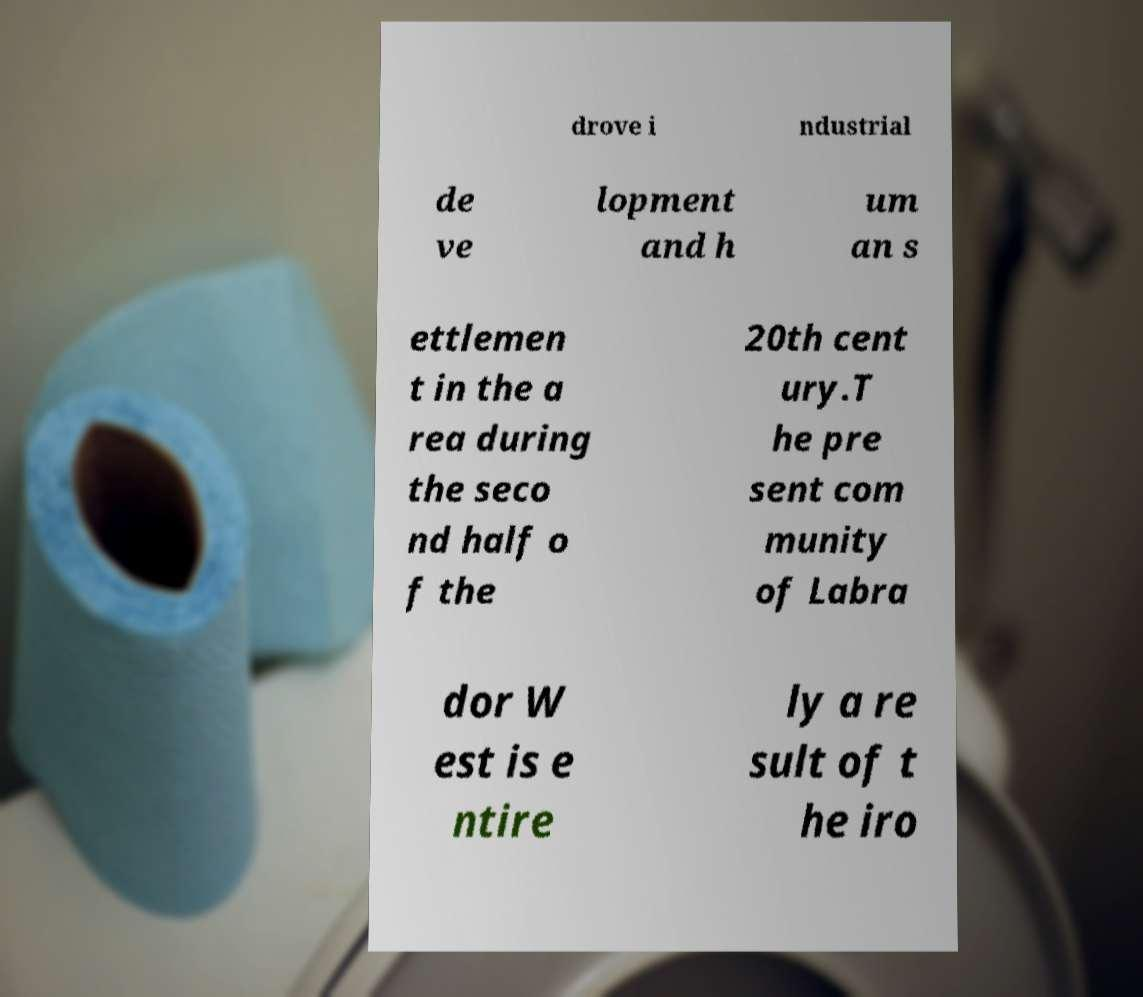Please read and relay the text visible in this image. What does it say? drove i ndustrial de ve lopment and h um an s ettlemen t in the a rea during the seco nd half o f the 20th cent ury.T he pre sent com munity of Labra dor W est is e ntire ly a re sult of t he iro 